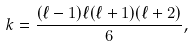<formula> <loc_0><loc_0><loc_500><loc_500>k = \frac { ( \ell - 1 ) \ell ( \ell + 1 ) ( \ell + 2 ) } { 6 } ,</formula> 